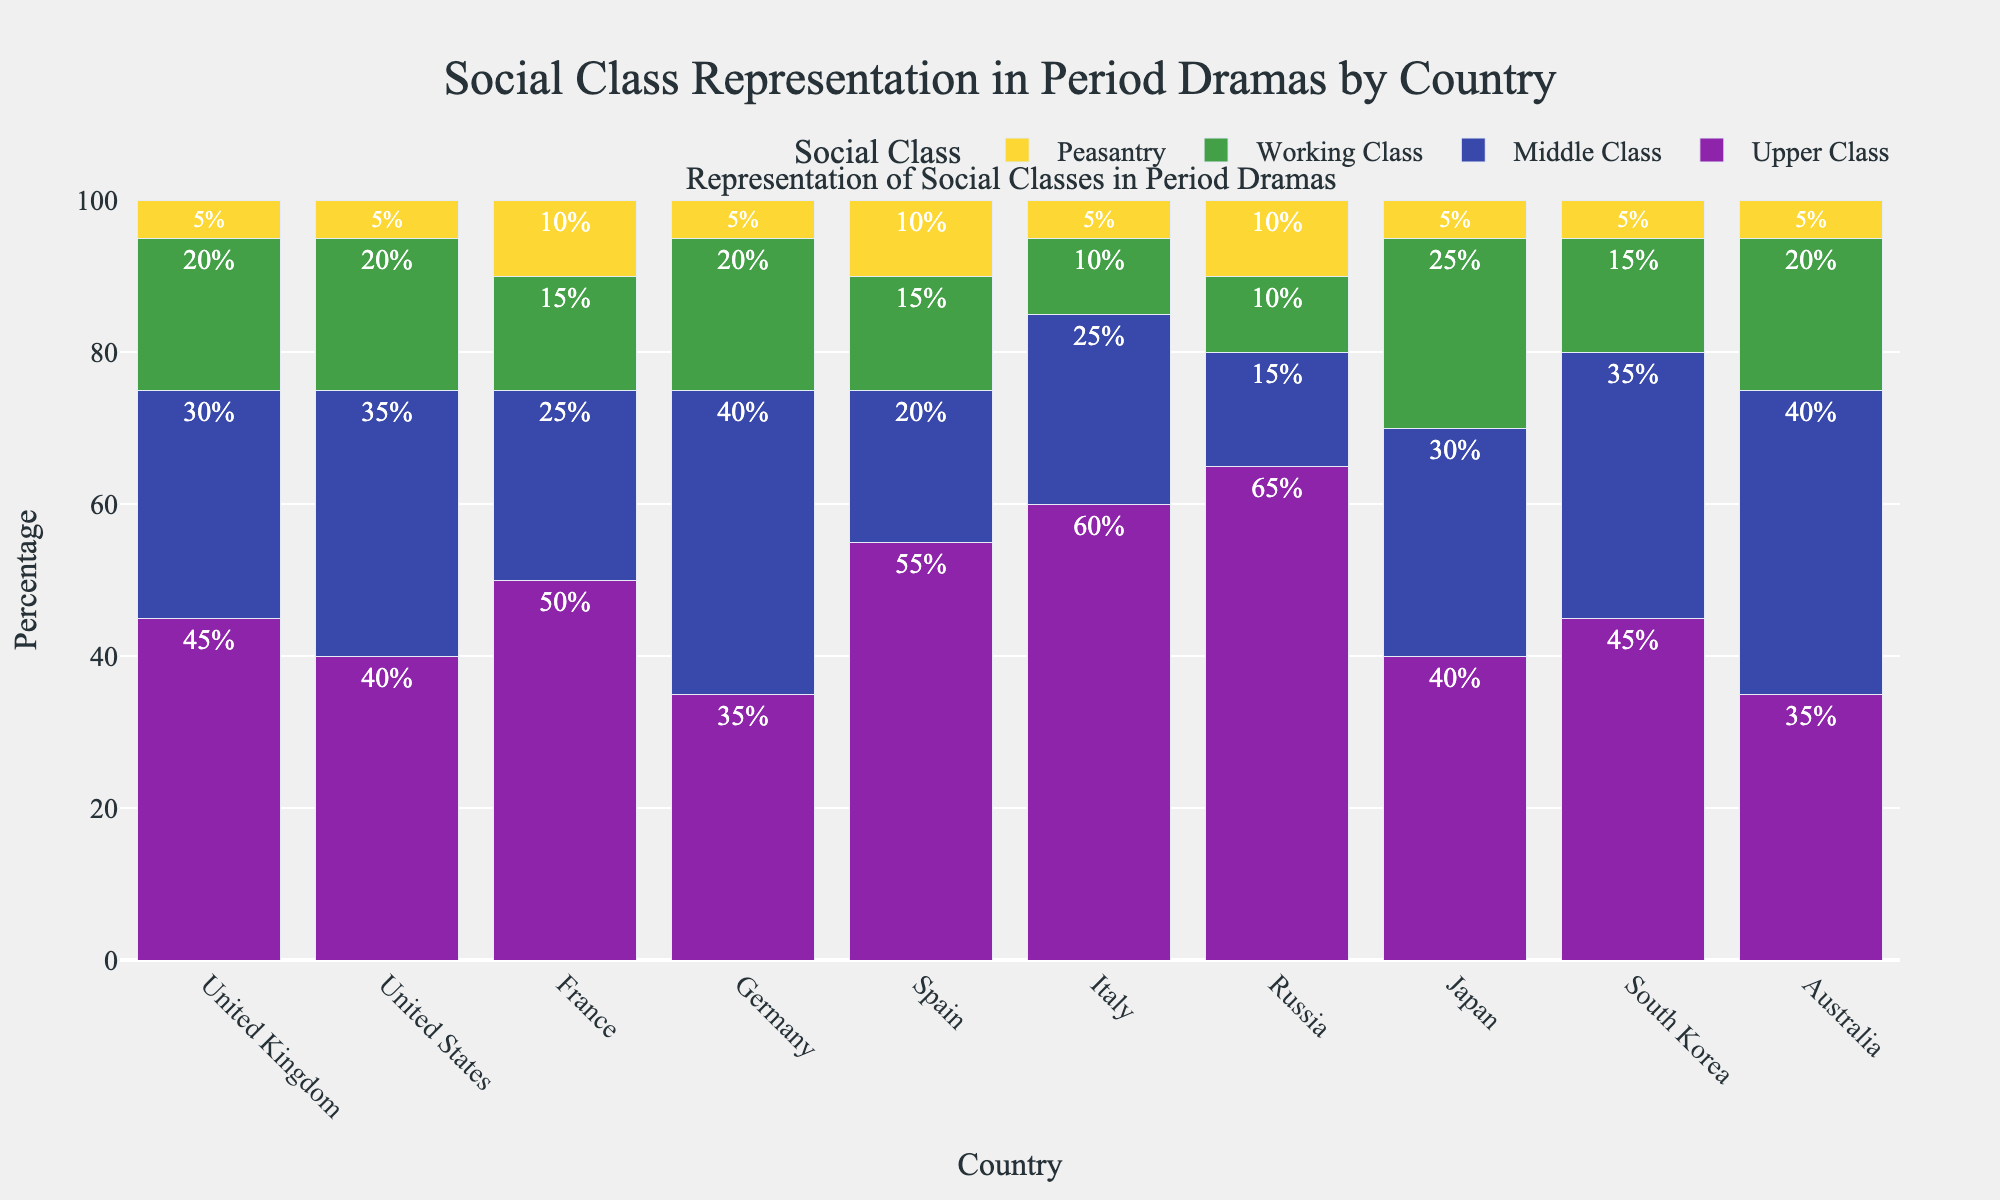Which country has the highest representation of the upper class? By looking at the heights of the bars, Russia has the tallest bar in the upper class category with 65%.
Answer: Russia Which social class has the lowest representation in Italy? By examining the bars for Italy, the peasantry bar is the shortest, representing 5%.
Answer: Peasantry How does the representation of the middle class in Germany compare to that in Australia? Germany's middle class bar is at 40%, while Australia's is also at 40%. Therefore, they are equal.
Answer: Equal What is the total representation of all social classes in the United Kingdom? Add the percentages for the United Kingdom from all social classes: 45% (Upper Class) + 30% (Middle Class) + 20% (Working Class) + 5% (Peasantry) = 100%.
Answer: 100% Which country shows a greater representation of the working class, Japan or Spain? Japan’s working class bar is at 25%, and Spain’s is at 15%. Thus, Japan has a greater representation of the working class.
Answer: Japan What is the average representation of the peasantry across all countries? Sum the peasantry percentages for all countries and divide by the number of countries: (5 + 5 + 10 + 5 + 10 + 5 + 10 + 5 + 5 + 5) / 10 = 6%.
Answer: 6% Among the countries shown, which one has the most balanced representation (least disparity between the highest and lowest percentages) across the social classes? Calculate the percentage differences for each country and find the smallest one. Italy has the percentages 60%, 25%, 10%, 5%, giving a range of 55%, which seems more balanced compared to other countries.
Answer: Italy Which social class category uses the green color in the figure? By looking at the color strips in the legend, green represents the Working Class.
Answer: Working Class In which country is the representation of the middle class the highest? Checking the bars for the middle class, the United States, Germany, and Australia have the highest representation at 40%.
Answer: United States, Germany, Australia How much higher is the representation of the peasantry in Russia compared to Japan? Russia's peasantry bar is at 10%, and Japan's is at 5%. The difference is 10% - 5% = 5%.
Answer: 5% 